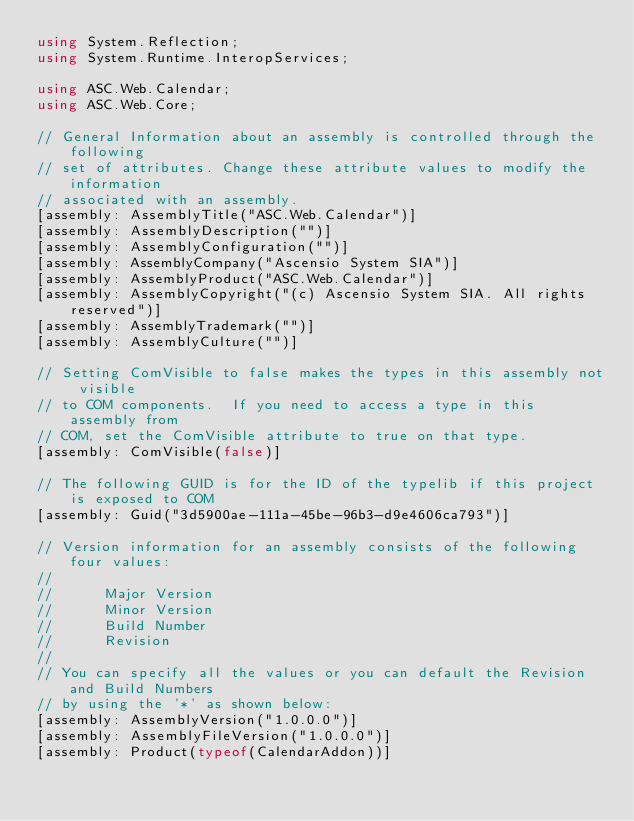<code> <loc_0><loc_0><loc_500><loc_500><_C#_>using System.Reflection;
using System.Runtime.InteropServices;

using ASC.Web.Calendar;
using ASC.Web.Core;

// General Information about an assembly is controlled through the following 
// set of attributes. Change these attribute values to modify the information
// associated with an assembly.
[assembly: AssemblyTitle("ASC.Web.Calendar")]
[assembly: AssemblyDescription("")]
[assembly: AssemblyConfiguration("")]
[assembly: AssemblyCompany("Ascensio System SIA")]
[assembly: AssemblyProduct("ASC.Web.Calendar")]
[assembly: AssemblyCopyright("(c) Ascensio System SIA. All rights reserved")]
[assembly: AssemblyTrademark("")]
[assembly: AssemblyCulture("")]

// Setting ComVisible to false makes the types in this assembly not visible 
// to COM components.  If you need to access a type in this assembly from 
// COM, set the ComVisible attribute to true on that type.
[assembly: ComVisible(false)]

// The following GUID is for the ID of the typelib if this project is exposed to COM
[assembly: Guid("3d5900ae-111a-45be-96b3-d9e4606ca793")]

// Version information for an assembly consists of the following four values:
//
//      Major Version
//      Minor Version 
//      Build Number
//      Revision
//
// You can specify all the values or you can default the Revision and Build Numbers 
// by using the '*' as shown below:
[assembly: AssemblyVersion("1.0.0.0")]
[assembly: AssemblyFileVersion("1.0.0.0")]
[assembly: Product(typeof(CalendarAddon))]
</code> 